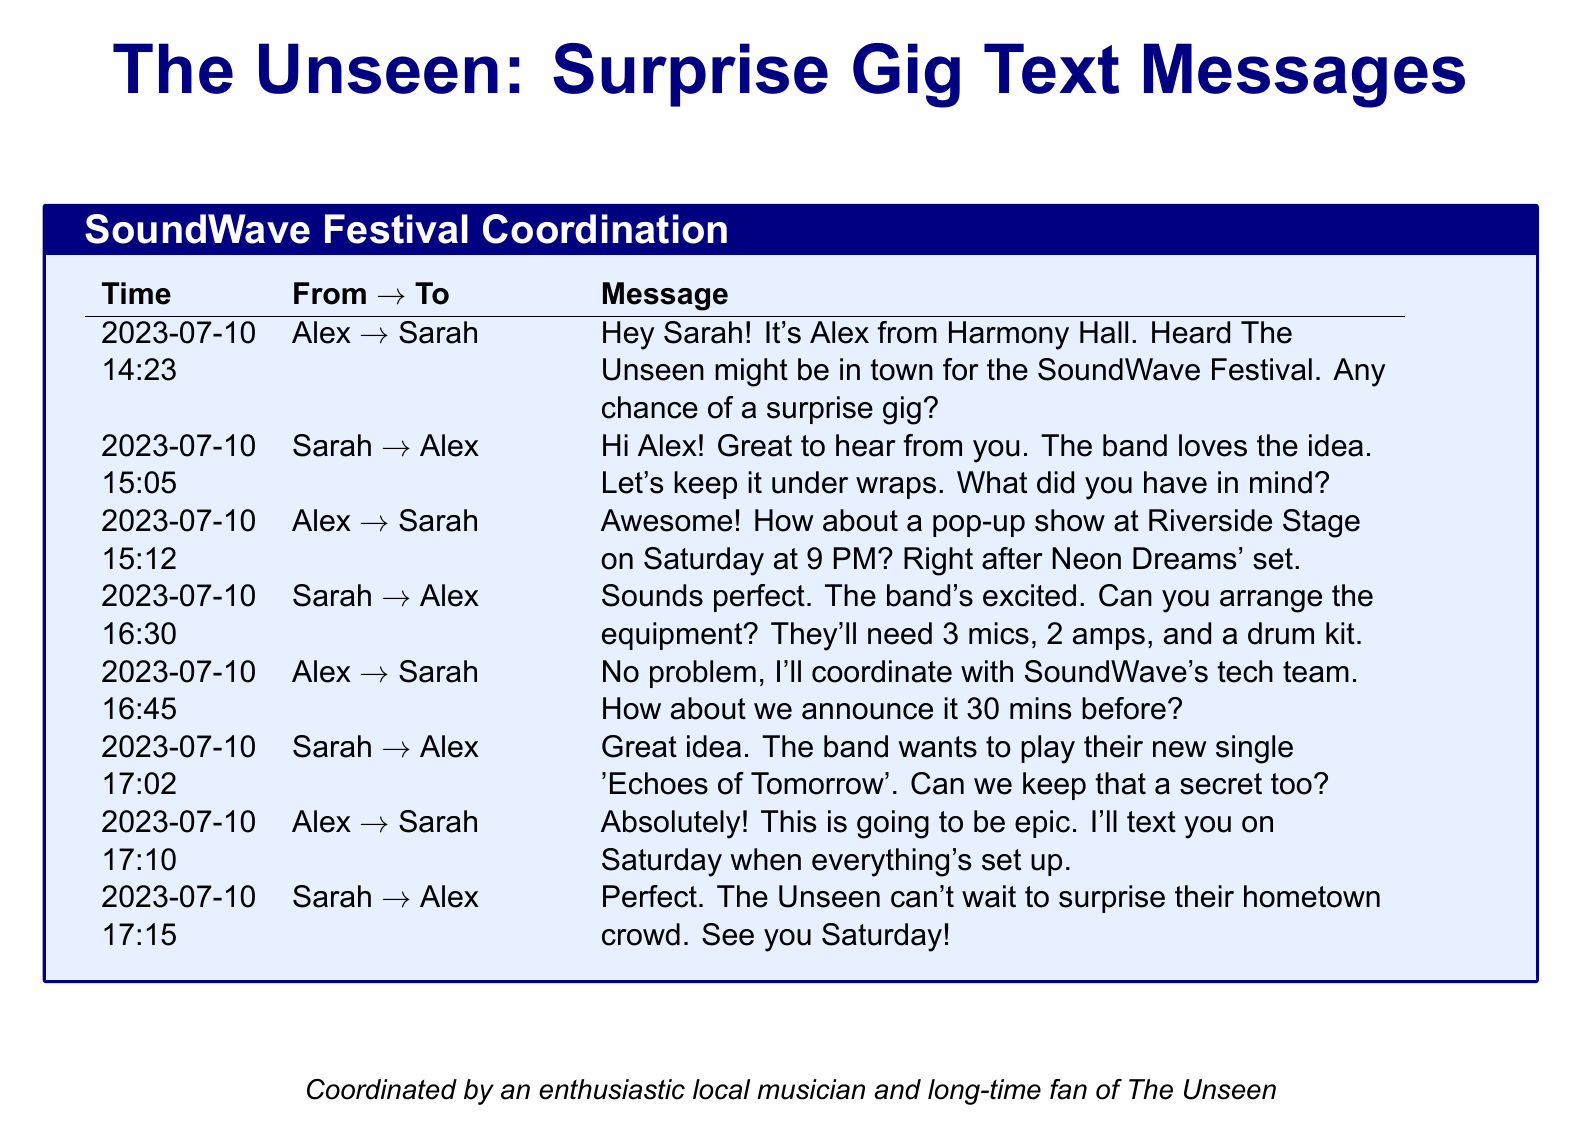What date was the first message sent? The first message was sent on July 10, 2023, as shown in the timestamp.
Answer: July 10, 2023 Who suggested the pop-up show? Alex initiated the idea for the surprise performance in his message.
Answer: Alex What time is the scheduled performance? The planned time for the surprise performance is mentioned in the document.
Answer: 9 PM How many microphones are needed for the performance? The text states the equipment needed, including microphones.
Answer: 3 mics What is the name of The Unseen's new single they want to play? Sarah mentions the new single in her message, highlighting the band's excitement.
Answer: Echoes of Tomorrow When will the announcement for the surprise gig be made? Alex suggests timing the announcement before the performance starts.
Answer: 30 mins before Who needs to arrange the equipment for the performance? Sarah asks Alex to manage the equipment logistics in her response.
Answer: Alex How did Sarah describe the band's reaction to the surprise gig? Sarah expresses the band's enthusiasm regarding the surprise performance.
Answer: The band loves the idea What was the main location for the surprise performance? The location for the gig is referenced in the message about where they planned the show.
Answer: Riverside Stage 